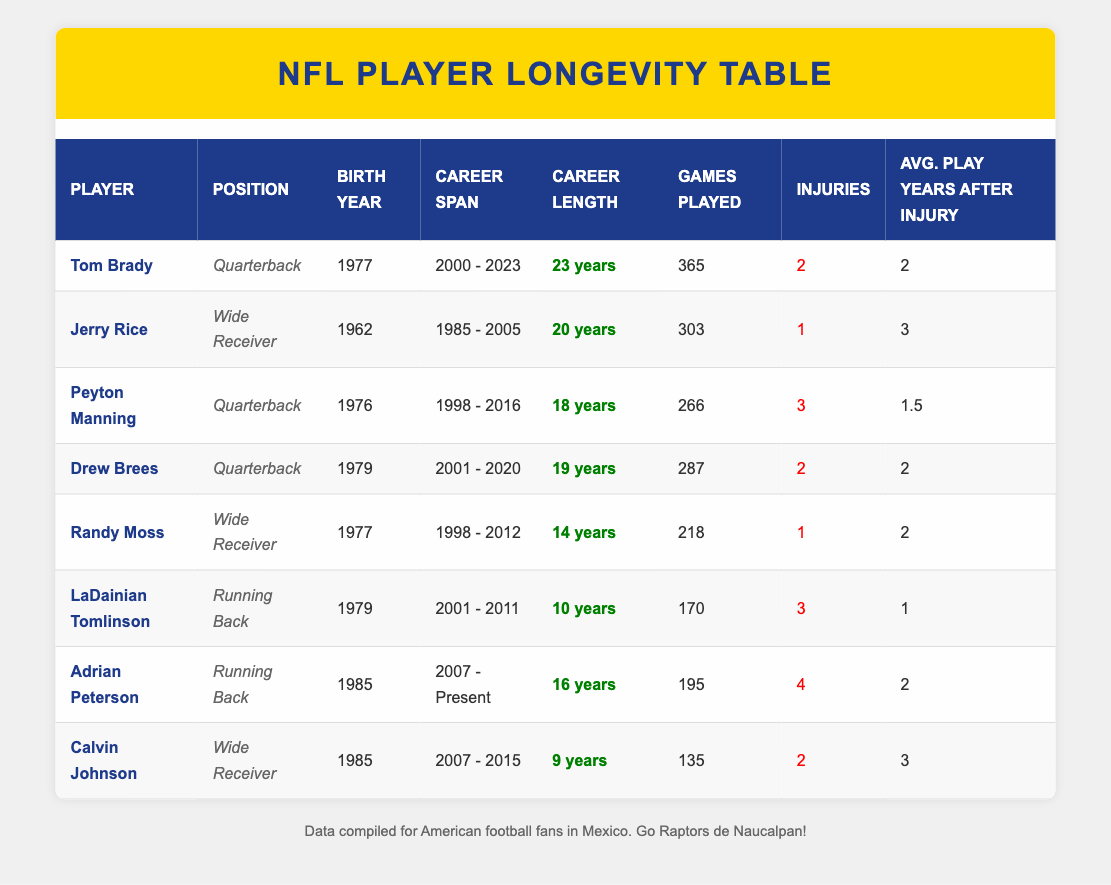How many games did Tom Brady play during his career? The table indicates that Tom Brady played 365 games throughout his career.
Answer: 365 What was the career length of Peyton Manning? The table states that Peyton Manning had a career length of 18 years.
Answer: 18 years Did any player retire without suffering injuries? By examining the table, it is clear that all players listed have an injury record, indicating none were injury-free during their careers.
Answer: No Which player had the highest average play years after injury? By comparing the "average play years after injury" column, Jerry Rice has the highest value at 3 years.
Answer: 3 years What is the average career length of the listed players? The total career lengths of all players (23 + 20 + 18 + 19 + 14 + 10 + 16 + 9 = 129 years) divided by 8 players gives an average of 16.125 years.
Answer: 16.125 years Did Drew Brees play more games than LaDainian Tomlinson? Drew Brees played 287 games compared to LaDainian Tomlinson’s 170 games, so the statement is true.
Answer: Yes Which player has the longest career span? Tom Brady's career span is from 2000 to 2023, which totals 23 years, the longest among the listed players.
Answer: 23 years If we consider only players who played as wide receivers, what is the average number of games played? Summing the games played by Jerry Rice (303) and Randy Moss (218) gives 521 games. Divided by 2 players, the average is 260.5 games.
Answer: 260.5 games Who had the fewest total games played in their career? Calvin Johnson played 135 games, which is fewer than the other listed players.
Answer: 135 games 